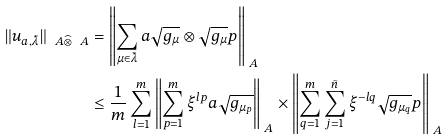Convert formula to latex. <formula><loc_0><loc_0><loc_500><loc_500>\| u _ { a , \tilde { \lambda } } \| _ { \ A \widehat { \otimes } \ A } & = \left \| \sum _ { \mu \in \tilde { \lambda } } a \sqrt { g _ { \mu } } \otimes \sqrt { g _ { \mu } } p \right \| _ { \ A } \\ & \leq \frac { 1 } { m } \sum _ { l = 1 } ^ { m } \left \| \sum _ { p = 1 } ^ { m } \xi ^ { l p } a \sqrt { g _ { \mu _ { p } } } \right \| _ { \ A } \times \left \| \sum _ { q = 1 } ^ { m } \sum _ { j = 1 } ^ { \tilde { n } } \xi ^ { - l q } \sqrt { g _ { \mu _ { q } } } p \right \| _ { \ A }</formula> 